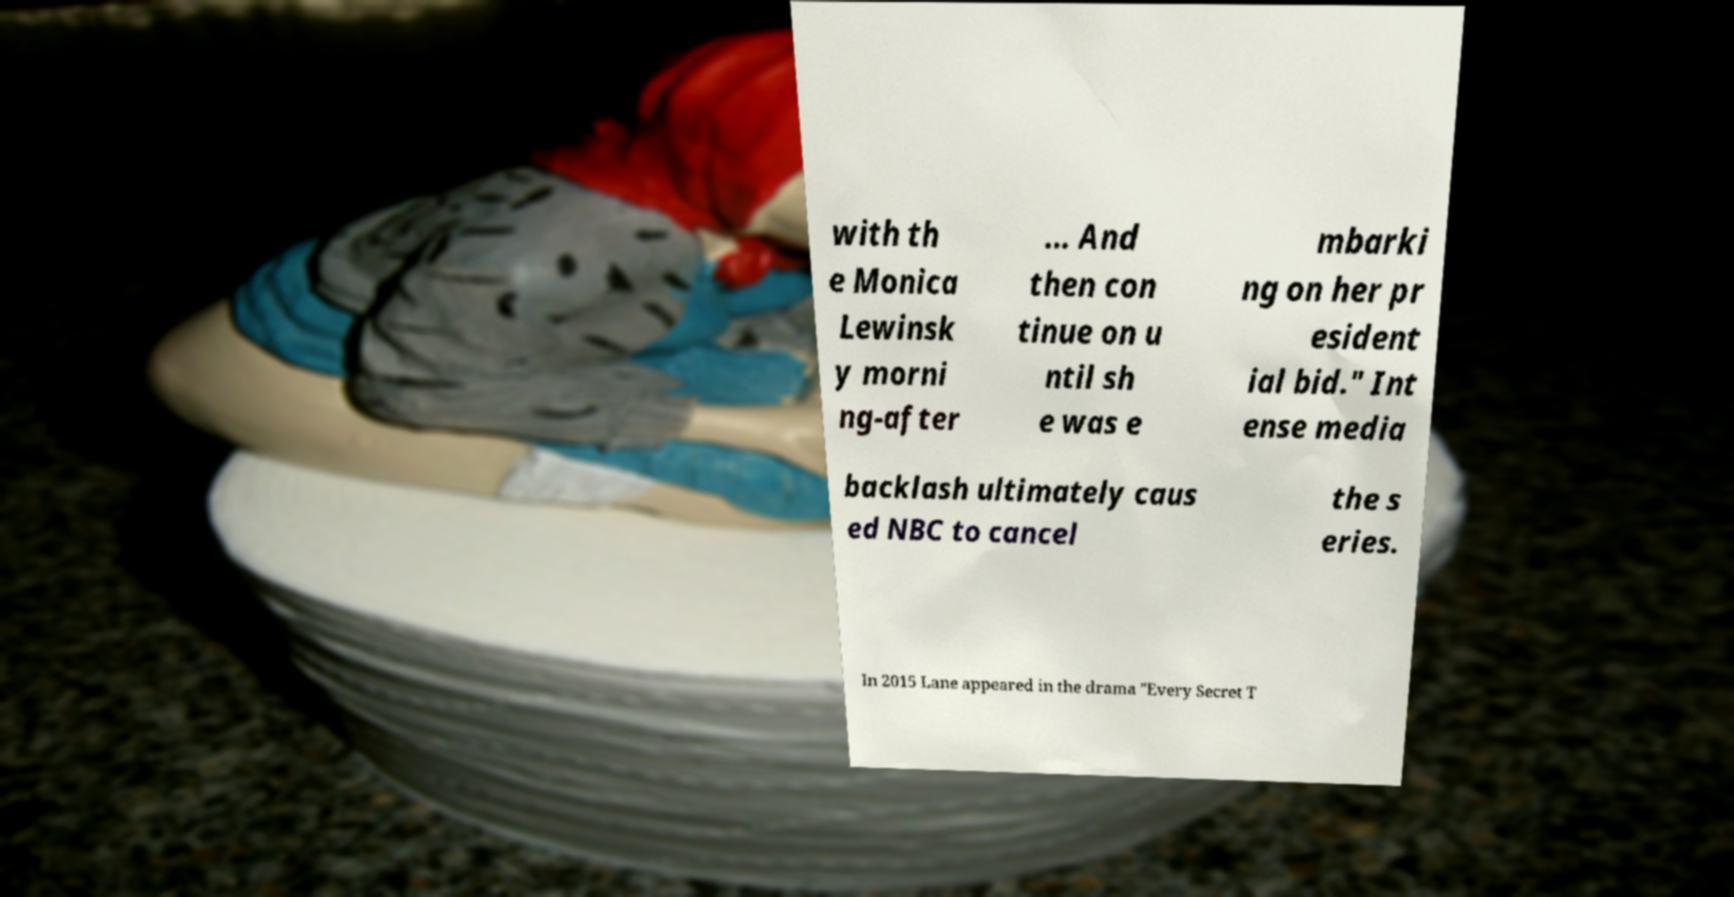There's text embedded in this image that I need extracted. Can you transcribe it verbatim? with th e Monica Lewinsk y morni ng-after ... And then con tinue on u ntil sh e was e mbarki ng on her pr esident ial bid." Int ense media backlash ultimately caus ed NBC to cancel the s eries. In 2015 Lane appeared in the drama "Every Secret T 